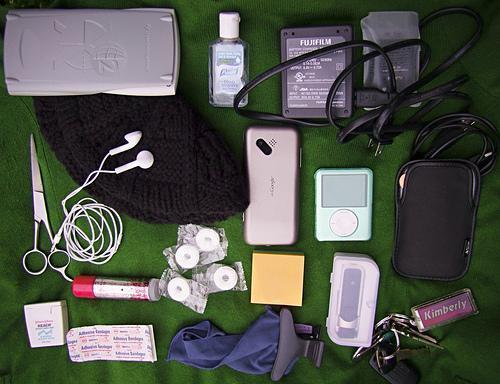How many bottles are there?
Give a very brief answer. 1. 